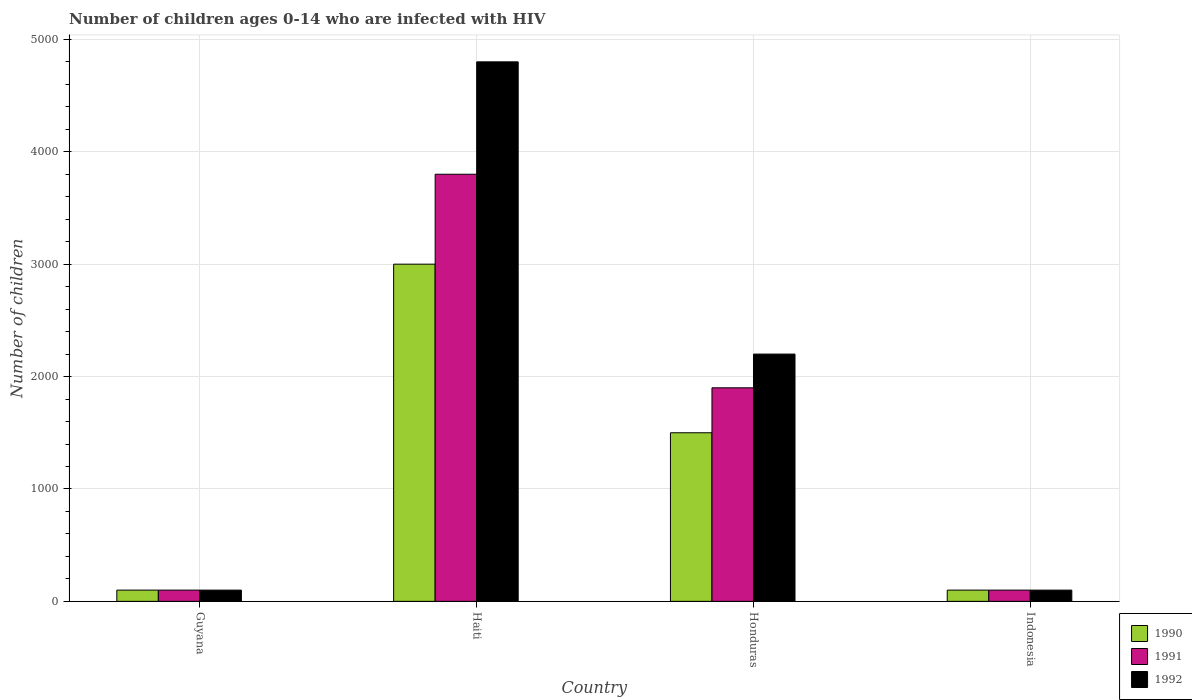How many different coloured bars are there?
Make the answer very short. 3. Are the number of bars per tick equal to the number of legend labels?
Give a very brief answer. Yes. How many bars are there on the 4th tick from the left?
Keep it short and to the point. 3. How many bars are there on the 1st tick from the right?
Make the answer very short. 3. What is the label of the 2nd group of bars from the left?
Your response must be concise. Haiti. What is the number of HIV infected children in 1992 in Honduras?
Keep it short and to the point. 2200. Across all countries, what is the maximum number of HIV infected children in 1990?
Offer a very short reply. 3000. Across all countries, what is the minimum number of HIV infected children in 1991?
Provide a succinct answer. 100. In which country was the number of HIV infected children in 1992 maximum?
Offer a very short reply. Haiti. In which country was the number of HIV infected children in 1992 minimum?
Keep it short and to the point. Guyana. What is the total number of HIV infected children in 1991 in the graph?
Provide a short and direct response. 5900. What is the difference between the number of HIV infected children in 1991 in Guyana and that in Honduras?
Offer a terse response. -1800. What is the difference between the number of HIV infected children in 1991 in Indonesia and the number of HIV infected children in 1992 in Honduras?
Your answer should be compact. -2100. What is the average number of HIV infected children in 1990 per country?
Your response must be concise. 1175. What is the difference between the number of HIV infected children of/in 1990 and number of HIV infected children of/in 1991 in Honduras?
Give a very brief answer. -400. In how many countries, is the number of HIV infected children in 1991 greater than 3400?
Your answer should be very brief. 1. What is the ratio of the number of HIV infected children in 1992 in Guyana to that in Indonesia?
Your response must be concise. 1. Is the difference between the number of HIV infected children in 1990 in Guyana and Honduras greater than the difference between the number of HIV infected children in 1991 in Guyana and Honduras?
Ensure brevity in your answer.  Yes. What is the difference between the highest and the second highest number of HIV infected children in 1991?
Provide a succinct answer. 3700. What is the difference between the highest and the lowest number of HIV infected children in 1992?
Provide a short and direct response. 4700. In how many countries, is the number of HIV infected children in 1991 greater than the average number of HIV infected children in 1991 taken over all countries?
Offer a terse response. 2. Is the sum of the number of HIV infected children in 1990 in Guyana and Haiti greater than the maximum number of HIV infected children in 1992 across all countries?
Provide a succinct answer. No. What does the 2nd bar from the left in Guyana represents?
Your answer should be very brief. 1991. What does the 3rd bar from the right in Haiti represents?
Make the answer very short. 1990. Are all the bars in the graph horizontal?
Your answer should be compact. No. How many countries are there in the graph?
Offer a very short reply. 4. Where does the legend appear in the graph?
Provide a succinct answer. Bottom right. How are the legend labels stacked?
Offer a terse response. Vertical. What is the title of the graph?
Offer a terse response. Number of children ages 0-14 who are infected with HIV. Does "1966" appear as one of the legend labels in the graph?
Your answer should be very brief. No. What is the label or title of the X-axis?
Ensure brevity in your answer.  Country. What is the label or title of the Y-axis?
Ensure brevity in your answer.  Number of children. What is the Number of children of 1990 in Guyana?
Keep it short and to the point. 100. What is the Number of children in 1990 in Haiti?
Ensure brevity in your answer.  3000. What is the Number of children in 1991 in Haiti?
Your answer should be compact. 3800. What is the Number of children of 1992 in Haiti?
Your answer should be compact. 4800. What is the Number of children in 1990 in Honduras?
Your answer should be compact. 1500. What is the Number of children of 1991 in Honduras?
Provide a succinct answer. 1900. What is the Number of children of 1992 in Honduras?
Provide a short and direct response. 2200. Across all countries, what is the maximum Number of children of 1990?
Offer a very short reply. 3000. Across all countries, what is the maximum Number of children in 1991?
Offer a very short reply. 3800. Across all countries, what is the maximum Number of children in 1992?
Your response must be concise. 4800. Across all countries, what is the minimum Number of children of 1992?
Ensure brevity in your answer.  100. What is the total Number of children in 1990 in the graph?
Make the answer very short. 4700. What is the total Number of children of 1991 in the graph?
Your answer should be compact. 5900. What is the total Number of children in 1992 in the graph?
Your answer should be very brief. 7200. What is the difference between the Number of children of 1990 in Guyana and that in Haiti?
Offer a terse response. -2900. What is the difference between the Number of children in 1991 in Guyana and that in Haiti?
Make the answer very short. -3700. What is the difference between the Number of children in 1992 in Guyana and that in Haiti?
Your response must be concise. -4700. What is the difference between the Number of children in 1990 in Guyana and that in Honduras?
Ensure brevity in your answer.  -1400. What is the difference between the Number of children in 1991 in Guyana and that in Honduras?
Offer a very short reply. -1800. What is the difference between the Number of children in 1992 in Guyana and that in Honduras?
Ensure brevity in your answer.  -2100. What is the difference between the Number of children in 1992 in Guyana and that in Indonesia?
Keep it short and to the point. 0. What is the difference between the Number of children in 1990 in Haiti and that in Honduras?
Provide a succinct answer. 1500. What is the difference between the Number of children of 1991 in Haiti and that in Honduras?
Your answer should be very brief. 1900. What is the difference between the Number of children of 1992 in Haiti and that in Honduras?
Keep it short and to the point. 2600. What is the difference between the Number of children of 1990 in Haiti and that in Indonesia?
Your answer should be very brief. 2900. What is the difference between the Number of children in 1991 in Haiti and that in Indonesia?
Give a very brief answer. 3700. What is the difference between the Number of children in 1992 in Haiti and that in Indonesia?
Give a very brief answer. 4700. What is the difference between the Number of children of 1990 in Honduras and that in Indonesia?
Your answer should be very brief. 1400. What is the difference between the Number of children in 1991 in Honduras and that in Indonesia?
Give a very brief answer. 1800. What is the difference between the Number of children of 1992 in Honduras and that in Indonesia?
Offer a very short reply. 2100. What is the difference between the Number of children in 1990 in Guyana and the Number of children in 1991 in Haiti?
Provide a short and direct response. -3700. What is the difference between the Number of children of 1990 in Guyana and the Number of children of 1992 in Haiti?
Provide a short and direct response. -4700. What is the difference between the Number of children of 1991 in Guyana and the Number of children of 1992 in Haiti?
Make the answer very short. -4700. What is the difference between the Number of children in 1990 in Guyana and the Number of children in 1991 in Honduras?
Offer a terse response. -1800. What is the difference between the Number of children in 1990 in Guyana and the Number of children in 1992 in Honduras?
Keep it short and to the point. -2100. What is the difference between the Number of children of 1991 in Guyana and the Number of children of 1992 in Honduras?
Your answer should be compact. -2100. What is the difference between the Number of children in 1991 in Guyana and the Number of children in 1992 in Indonesia?
Give a very brief answer. 0. What is the difference between the Number of children in 1990 in Haiti and the Number of children in 1991 in Honduras?
Offer a terse response. 1100. What is the difference between the Number of children of 1990 in Haiti and the Number of children of 1992 in Honduras?
Keep it short and to the point. 800. What is the difference between the Number of children in 1991 in Haiti and the Number of children in 1992 in Honduras?
Provide a short and direct response. 1600. What is the difference between the Number of children in 1990 in Haiti and the Number of children in 1991 in Indonesia?
Ensure brevity in your answer.  2900. What is the difference between the Number of children of 1990 in Haiti and the Number of children of 1992 in Indonesia?
Your answer should be very brief. 2900. What is the difference between the Number of children of 1991 in Haiti and the Number of children of 1992 in Indonesia?
Provide a succinct answer. 3700. What is the difference between the Number of children in 1990 in Honduras and the Number of children in 1991 in Indonesia?
Offer a very short reply. 1400. What is the difference between the Number of children in 1990 in Honduras and the Number of children in 1992 in Indonesia?
Offer a terse response. 1400. What is the difference between the Number of children of 1991 in Honduras and the Number of children of 1992 in Indonesia?
Offer a very short reply. 1800. What is the average Number of children of 1990 per country?
Give a very brief answer. 1175. What is the average Number of children in 1991 per country?
Offer a terse response. 1475. What is the average Number of children of 1992 per country?
Keep it short and to the point. 1800. What is the difference between the Number of children in 1990 and Number of children in 1991 in Guyana?
Ensure brevity in your answer.  0. What is the difference between the Number of children in 1990 and Number of children in 1992 in Guyana?
Ensure brevity in your answer.  0. What is the difference between the Number of children in 1990 and Number of children in 1991 in Haiti?
Provide a succinct answer. -800. What is the difference between the Number of children in 1990 and Number of children in 1992 in Haiti?
Keep it short and to the point. -1800. What is the difference between the Number of children of 1991 and Number of children of 1992 in Haiti?
Ensure brevity in your answer.  -1000. What is the difference between the Number of children of 1990 and Number of children of 1991 in Honduras?
Make the answer very short. -400. What is the difference between the Number of children in 1990 and Number of children in 1992 in Honduras?
Your response must be concise. -700. What is the difference between the Number of children in 1991 and Number of children in 1992 in Honduras?
Your answer should be compact. -300. What is the difference between the Number of children of 1990 and Number of children of 1991 in Indonesia?
Give a very brief answer. 0. What is the difference between the Number of children of 1990 and Number of children of 1992 in Indonesia?
Offer a terse response. 0. What is the ratio of the Number of children in 1990 in Guyana to that in Haiti?
Keep it short and to the point. 0.03. What is the ratio of the Number of children of 1991 in Guyana to that in Haiti?
Your answer should be very brief. 0.03. What is the ratio of the Number of children of 1992 in Guyana to that in Haiti?
Provide a succinct answer. 0.02. What is the ratio of the Number of children in 1990 in Guyana to that in Honduras?
Give a very brief answer. 0.07. What is the ratio of the Number of children of 1991 in Guyana to that in Honduras?
Keep it short and to the point. 0.05. What is the ratio of the Number of children in 1992 in Guyana to that in Honduras?
Your answer should be very brief. 0.05. What is the ratio of the Number of children in 1990 in Guyana to that in Indonesia?
Offer a terse response. 1. What is the ratio of the Number of children of 1991 in Guyana to that in Indonesia?
Provide a short and direct response. 1. What is the ratio of the Number of children of 1992 in Guyana to that in Indonesia?
Your answer should be very brief. 1. What is the ratio of the Number of children in 1991 in Haiti to that in Honduras?
Offer a terse response. 2. What is the ratio of the Number of children in 1992 in Haiti to that in Honduras?
Your answer should be compact. 2.18. What is the ratio of the Number of children of 1990 in Haiti to that in Indonesia?
Make the answer very short. 30. What is the ratio of the Number of children in 1991 in Haiti to that in Indonesia?
Your response must be concise. 38. What is the ratio of the Number of children in 1991 in Honduras to that in Indonesia?
Your response must be concise. 19. What is the difference between the highest and the second highest Number of children in 1990?
Your response must be concise. 1500. What is the difference between the highest and the second highest Number of children of 1991?
Keep it short and to the point. 1900. What is the difference between the highest and the second highest Number of children of 1992?
Ensure brevity in your answer.  2600. What is the difference between the highest and the lowest Number of children in 1990?
Your answer should be compact. 2900. What is the difference between the highest and the lowest Number of children of 1991?
Offer a very short reply. 3700. What is the difference between the highest and the lowest Number of children in 1992?
Your response must be concise. 4700. 